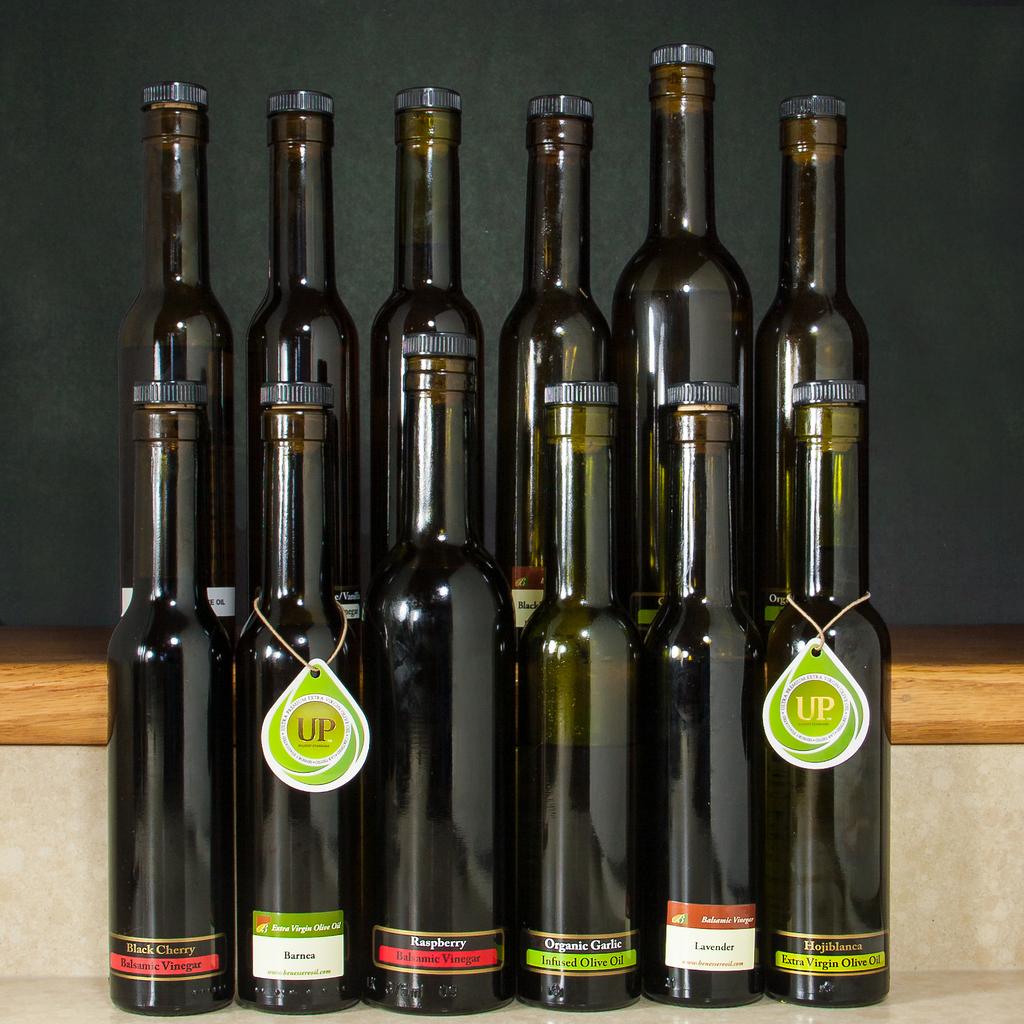Which kind of food product is contained in these bottles?
Keep it short and to the point. Olive oil. What flavor is in the bottle on the left?
Offer a very short reply. Black cherry. 